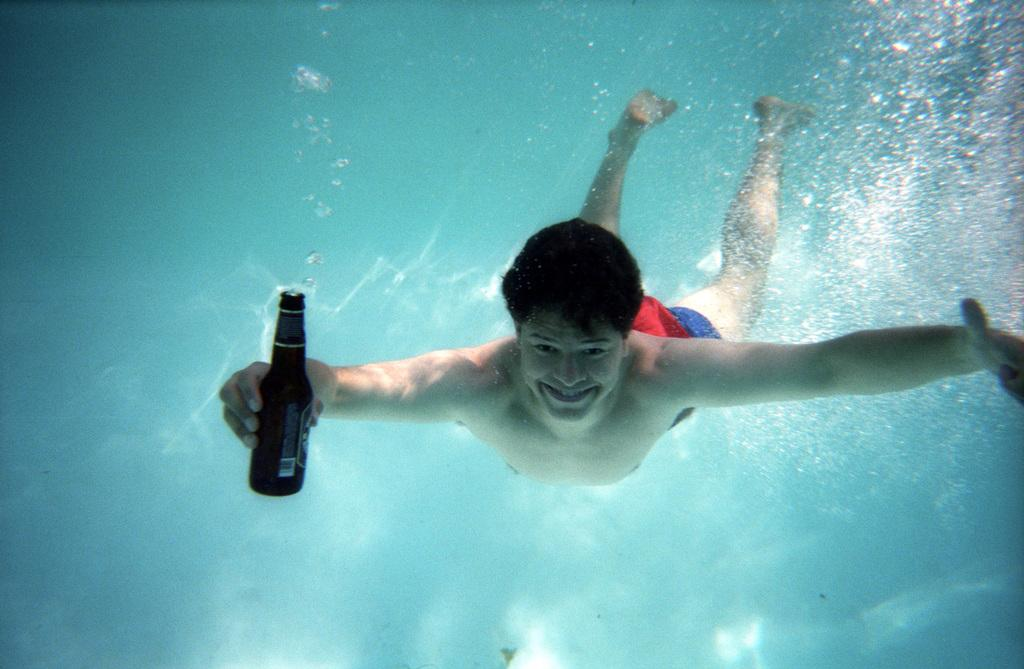Who is present in the image? There is a man in the image. What is the man doing in the image? The man is smiling in the image. What is the man holding in the image? The man is holding a bottle in one hand. Where is the man located in the image? The man is underwater in the image. What type of test is the man conducting underwater? There is no indication in the image that the man is conducting a test, so it cannot be determined from the picture. 